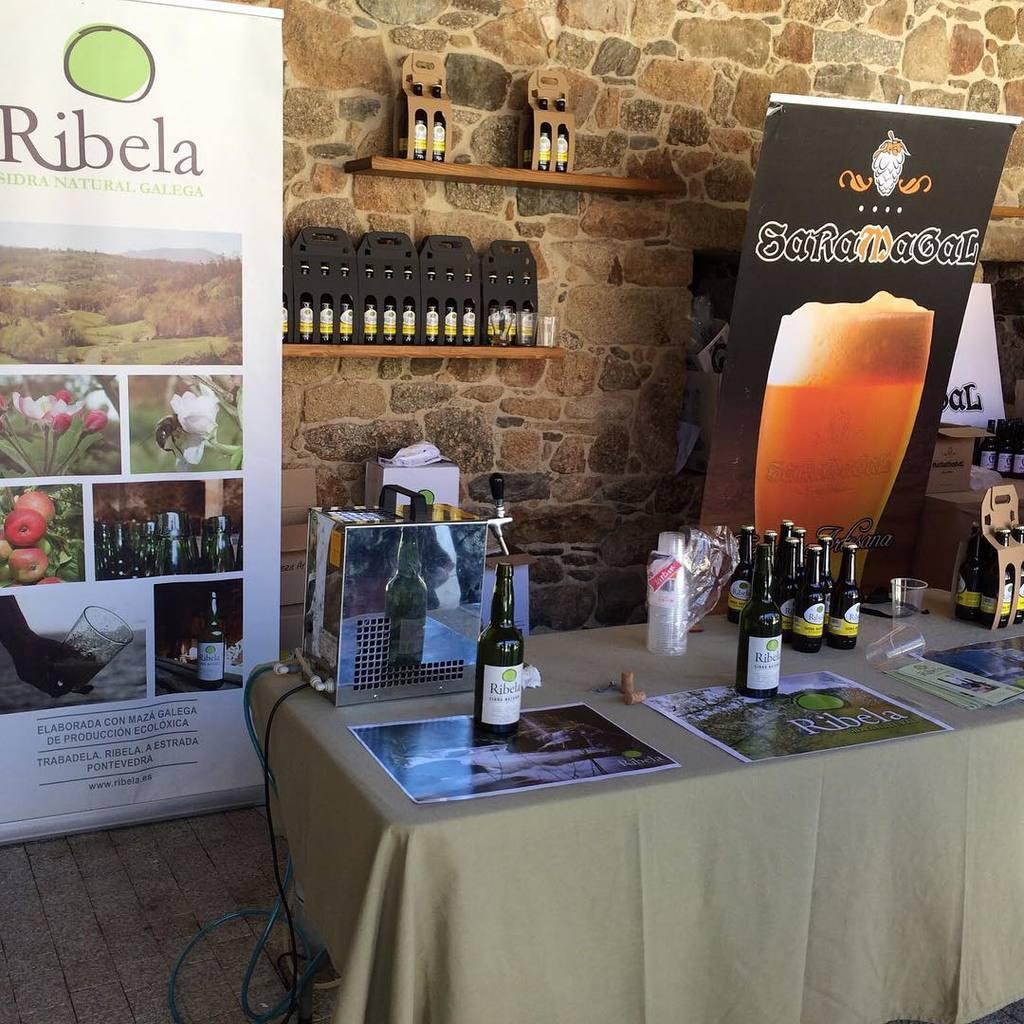Can you describe this image briefly? In this image i can see a table with few glasses on it. I can also see there is a banner on the wall. 